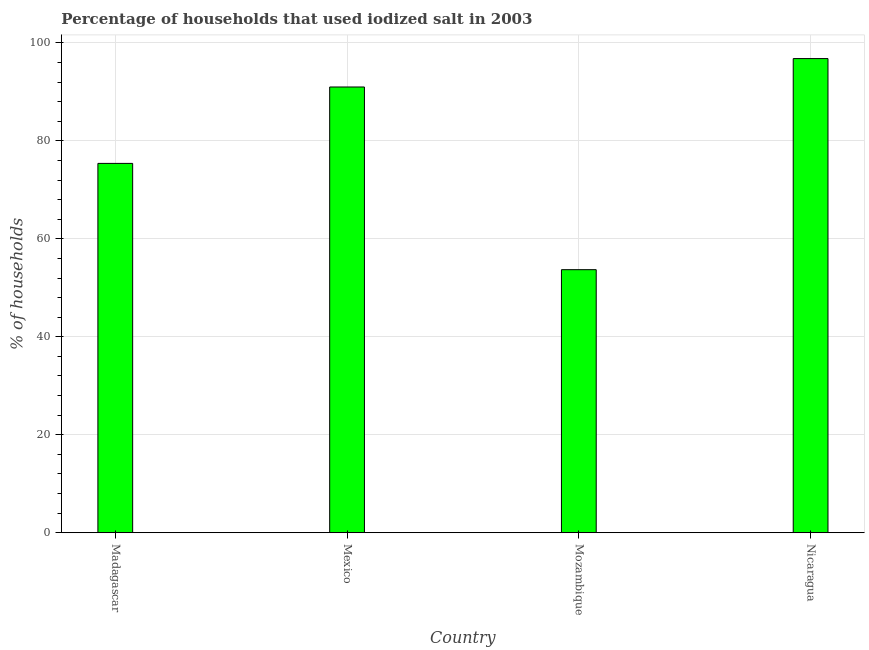Does the graph contain grids?
Ensure brevity in your answer.  Yes. What is the title of the graph?
Give a very brief answer. Percentage of households that used iodized salt in 2003. What is the label or title of the X-axis?
Offer a terse response. Country. What is the label or title of the Y-axis?
Provide a succinct answer. % of households. What is the percentage of households where iodized salt is consumed in Nicaragua?
Make the answer very short. 96.8. Across all countries, what is the maximum percentage of households where iodized salt is consumed?
Offer a very short reply. 96.8. Across all countries, what is the minimum percentage of households where iodized salt is consumed?
Keep it short and to the point. 53.7. In which country was the percentage of households where iodized salt is consumed maximum?
Make the answer very short. Nicaragua. In which country was the percentage of households where iodized salt is consumed minimum?
Make the answer very short. Mozambique. What is the sum of the percentage of households where iodized salt is consumed?
Your answer should be very brief. 316.9. What is the difference between the percentage of households where iodized salt is consumed in Madagascar and Nicaragua?
Your answer should be very brief. -21.4. What is the average percentage of households where iodized salt is consumed per country?
Ensure brevity in your answer.  79.22. What is the median percentage of households where iodized salt is consumed?
Give a very brief answer. 83.2. In how many countries, is the percentage of households where iodized salt is consumed greater than 64 %?
Provide a succinct answer. 3. What is the ratio of the percentage of households where iodized salt is consumed in Mexico to that in Mozambique?
Provide a succinct answer. 1.7. What is the difference between the highest and the second highest percentage of households where iodized salt is consumed?
Your response must be concise. 5.8. Is the sum of the percentage of households where iodized salt is consumed in Madagascar and Mexico greater than the maximum percentage of households where iodized salt is consumed across all countries?
Offer a terse response. Yes. What is the difference between the highest and the lowest percentage of households where iodized salt is consumed?
Provide a succinct answer. 43.1. How many bars are there?
Keep it short and to the point. 4. Are all the bars in the graph horizontal?
Make the answer very short. No. What is the difference between two consecutive major ticks on the Y-axis?
Give a very brief answer. 20. Are the values on the major ticks of Y-axis written in scientific E-notation?
Offer a terse response. No. What is the % of households in Madagascar?
Make the answer very short. 75.4. What is the % of households in Mexico?
Offer a very short reply. 91. What is the % of households in Mozambique?
Provide a short and direct response. 53.7. What is the % of households of Nicaragua?
Your answer should be very brief. 96.8. What is the difference between the % of households in Madagascar and Mexico?
Give a very brief answer. -15.6. What is the difference between the % of households in Madagascar and Mozambique?
Keep it short and to the point. 21.7. What is the difference between the % of households in Madagascar and Nicaragua?
Offer a very short reply. -21.4. What is the difference between the % of households in Mexico and Mozambique?
Your response must be concise. 37.3. What is the difference between the % of households in Mozambique and Nicaragua?
Provide a succinct answer. -43.1. What is the ratio of the % of households in Madagascar to that in Mexico?
Your answer should be compact. 0.83. What is the ratio of the % of households in Madagascar to that in Mozambique?
Provide a succinct answer. 1.4. What is the ratio of the % of households in Madagascar to that in Nicaragua?
Your response must be concise. 0.78. What is the ratio of the % of households in Mexico to that in Mozambique?
Make the answer very short. 1.7. What is the ratio of the % of households in Mexico to that in Nicaragua?
Offer a terse response. 0.94. What is the ratio of the % of households in Mozambique to that in Nicaragua?
Your answer should be very brief. 0.56. 